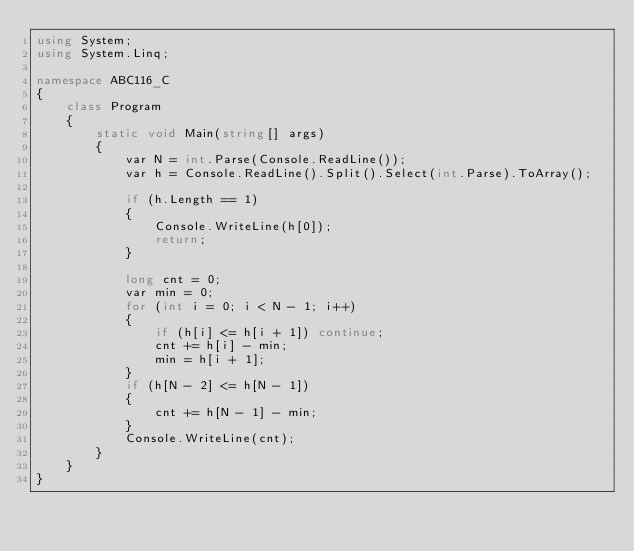<code> <loc_0><loc_0><loc_500><loc_500><_C#_>using System;
using System.Linq;

namespace ABC116_C
{
    class Program
    {
        static void Main(string[] args)
        {
            var N = int.Parse(Console.ReadLine());
            var h = Console.ReadLine().Split().Select(int.Parse).ToArray();

            if (h.Length == 1)
            {
                Console.WriteLine(h[0]);
                return;
            }

            long cnt = 0;
            var min = 0;
            for (int i = 0; i < N - 1; i++)
            {
                if (h[i] <= h[i + 1]) continue;
                cnt += h[i] - min;
                min = h[i + 1];
            }
            if (h[N - 2] <= h[N - 1])
            {
                cnt += h[N - 1] - min;
            }
            Console.WriteLine(cnt);
        }
    }
}
</code> 